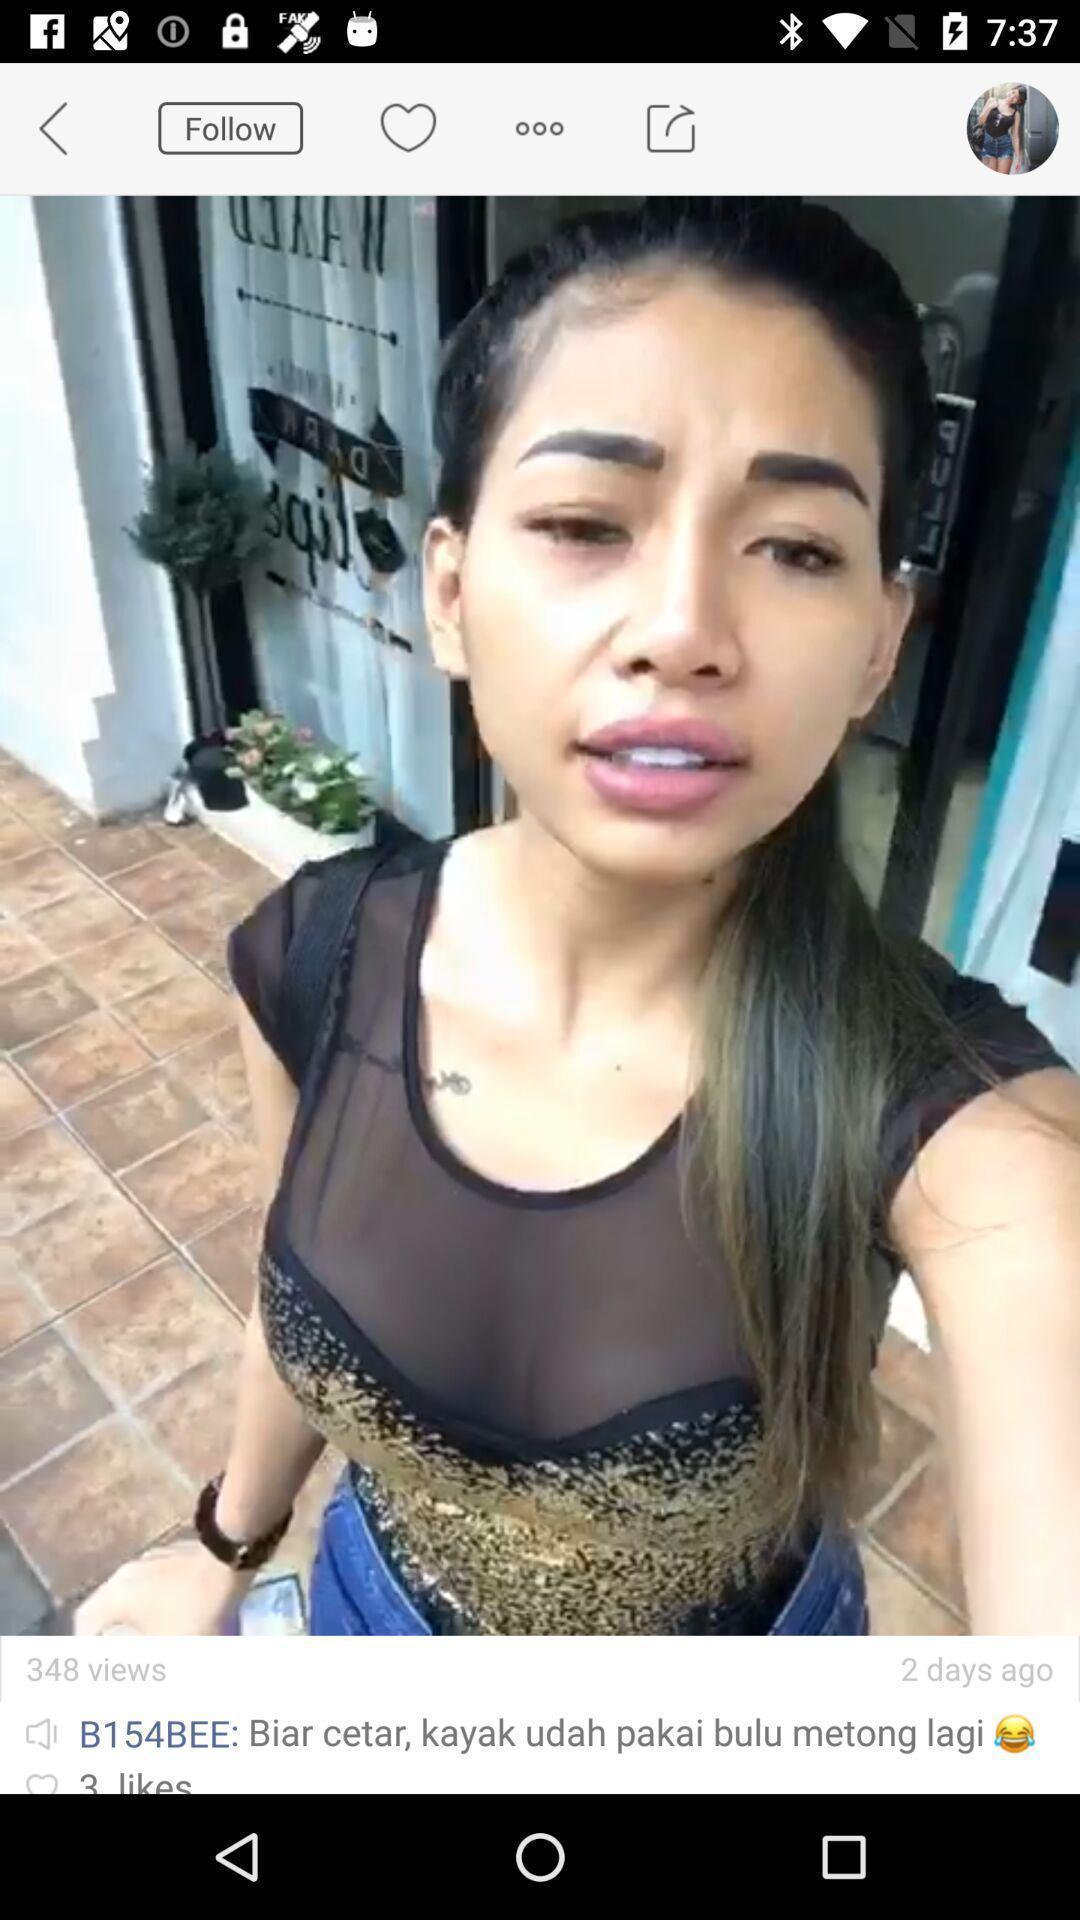Describe the key features of this screenshot. Screen shows image of girl with views. 